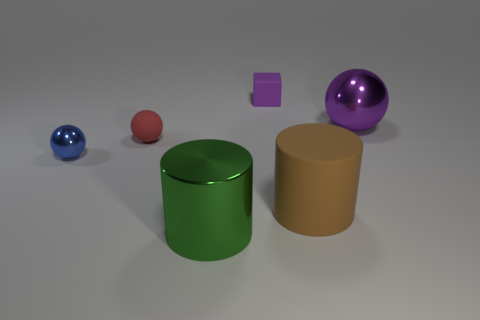Is the material of the big cylinder that is to the left of the small purple object the same as the blue ball?
Your answer should be very brief. Yes. There is a thing that is both in front of the cube and behind the red ball; what is its material?
Your answer should be compact. Metal. What is the size of the metal sphere that is the same color as the cube?
Offer a terse response. Large. The purple object that is behind the metallic thing behind the small metal thing is made of what material?
Ensure brevity in your answer.  Rubber. There is a object that is behind the big metallic sphere on the right side of the cylinder that is to the left of the small purple cube; how big is it?
Offer a very short reply. Small. How many large green cylinders are made of the same material as the small red thing?
Give a very brief answer. 0. There is a large metal object on the right side of the rubber object that is behind the large purple metal sphere; what is its color?
Provide a succinct answer. Purple. What number of things are either tiny cyan rubber things or spheres that are in front of the small red rubber sphere?
Offer a terse response. 1. Are there any other spheres that have the same color as the big sphere?
Ensure brevity in your answer.  No. What number of blue things are metal things or big things?
Keep it short and to the point. 1. 